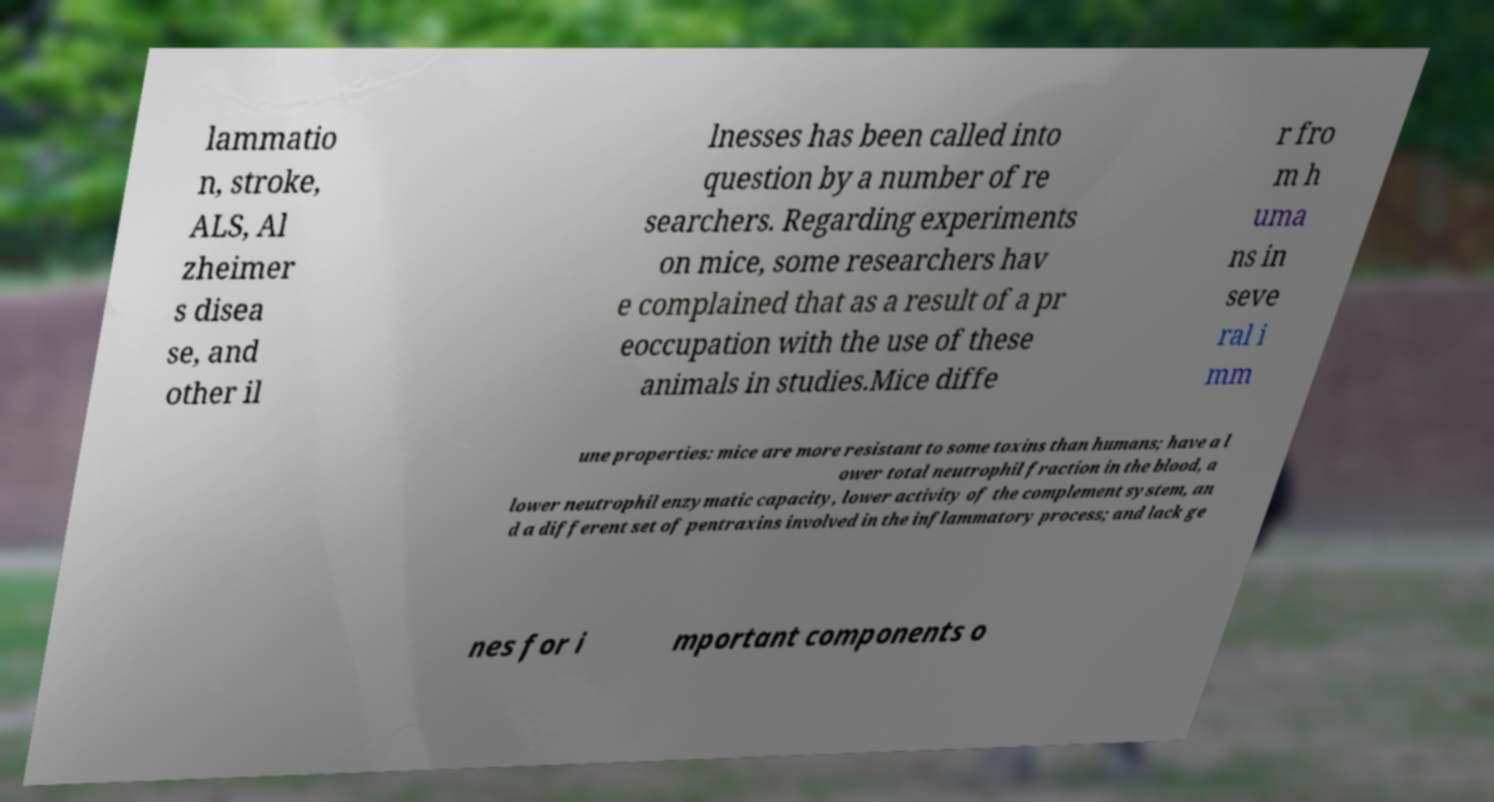What messages or text are displayed in this image? I need them in a readable, typed format. lammatio n, stroke, ALS, Al zheimer s disea se, and other il lnesses has been called into question by a number of re searchers. Regarding experiments on mice, some researchers hav e complained that as a result of a pr eoccupation with the use of these animals in studies.Mice diffe r fro m h uma ns in seve ral i mm une properties: mice are more resistant to some toxins than humans; have a l ower total neutrophil fraction in the blood, a lower neutrophil enzymatic capacity, lower activity of the complement system, an d a different set of pentraxins involved in the inflammatory process; and lack ge nes for i mportant components o 